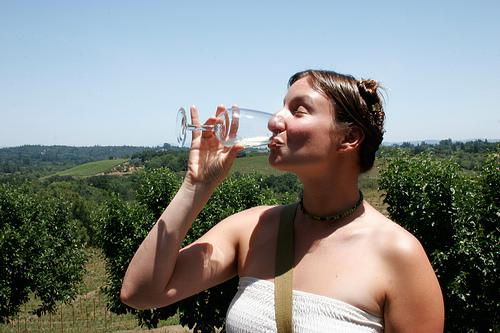Question: why is the glass almost empty?
Choices:
A. The woman is drinking from it.
B. It evaporated.
C. It was spilled.
D. Someone swapped glasses.
Answer with the letter. Answer: A Question: when during the day did this scene happen?
Choices:
A. At noon.
B. Daytime.
C. 9 a.m.
D. At brunch.
Answer with the letter. Answer: B Question: what type of top is the woman wearing?
Choices:
A. Crop top.
B. Tube top.
C. Turtle neck.
D. Sweater.
Answer with the letter. Answer: B Question: where is the scene happening?
Choices:
A. In the countryside.
B. In the city.
C. At the park.
D. In a factory.
Answer with the letter. Answer: A Question: who is in the scene?
Choices:
A. A woman.
B. A child.
C. A dog.
D. A penguin.
Answer with the letter. Answer: A Question: how is the woman carrying her bag?
Choices:
A. Across her shoulder.
B. In her hand.
C. Under her arm.
D. Around her neck.
Answer with the letter. Answer: A Question: what is in the woman's hand?
Choices:
A. A glass.
B. Her phone.
C. Wine.
D. A snack.
Answer with the letter. Answer: A 